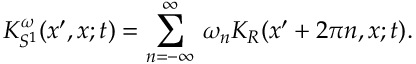<formula> <loc_0><loc_0><loc_500><loc_500>K _ { S ^ { 1 } } ^ { \omega } ( x ^ { \prime } , x ; t ) = \sum _ { n = - \infty } ^ { \infty } \, \omega _ { n } K _ { R } ( x ^ { \prime } + 2 \pi n , x ; t ) .</formula> 